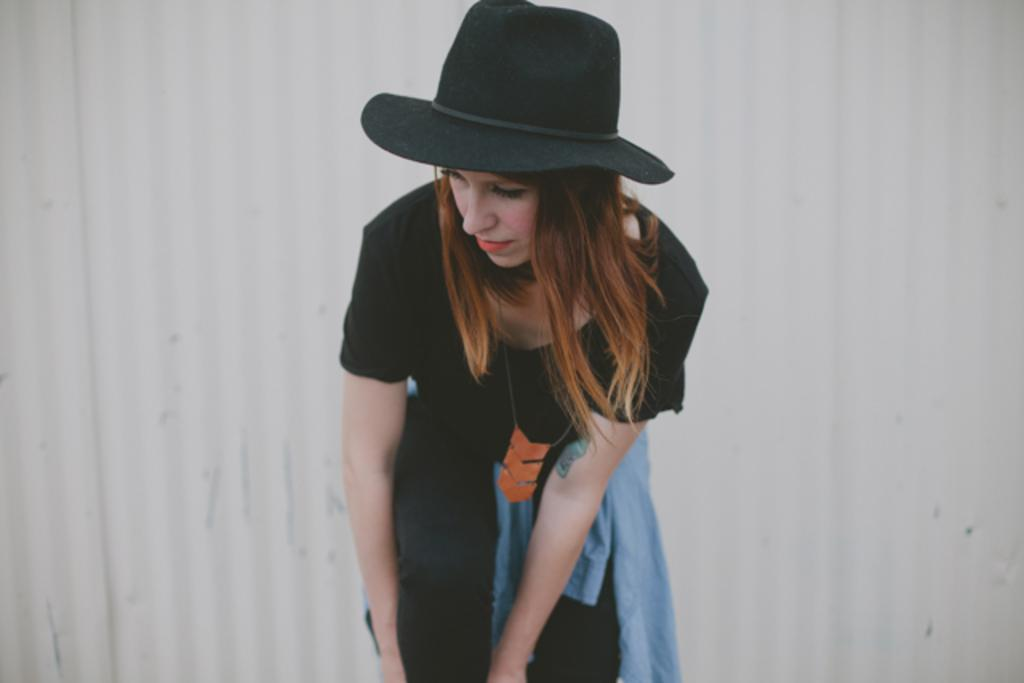Who is the main subject in the picture? There is a girl in the picture. What is the girl wearing? The girl is wearing a black t-shirt, black pants, and a black color hat. What can be seen behind the girl in the picture? There is a wall behind the girl. What is the color of the wall? The wall is white in color. What type of science experiment is the girl conducting in the picture? There is no indication of a science experiment in the picture; the girl is simply standing in front of a white wall. What kind of thread is being used to create the hat the girl is wearing? The facts do not mention any thread being used for the hat; it is described as a black color hat. 